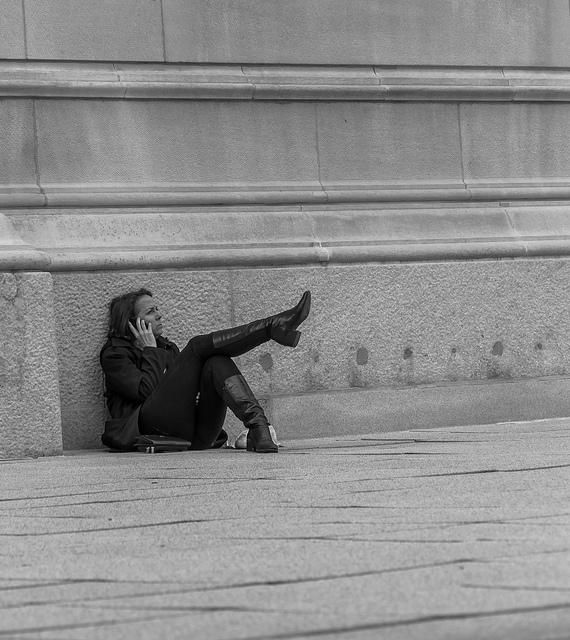What other people are known to sit in locations like this in this position?

Choices:
A) pan handlers
B) engineers
C) football players
D) teachers pan handlers 